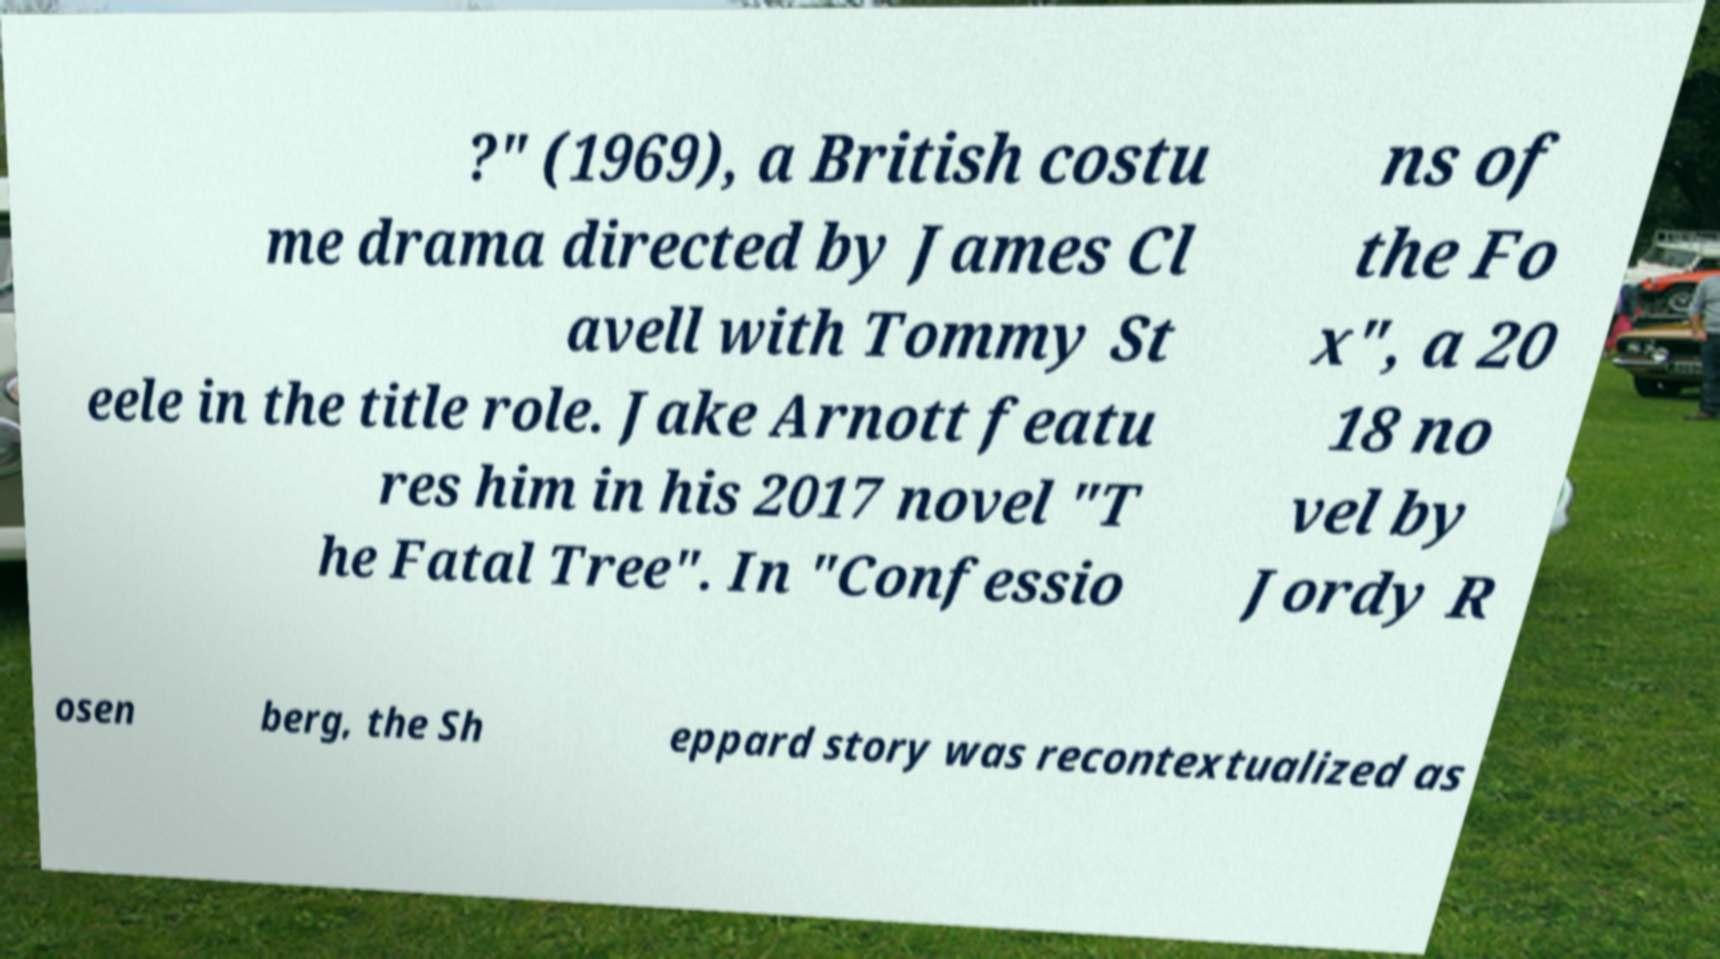Could you assist in decoding the text presented in this image and type it out clearly? ?" (1969), a British costu me drama directed by James Cl avell with Tommy St eele in the title role. Jake Arnott featu res him in his 2017 novel "T he Fatal Tree". In "Confessio ns of the Fo x", a 20 18 no vel by Jordy R osen berg, the Sh eppard story was recontextualized as 